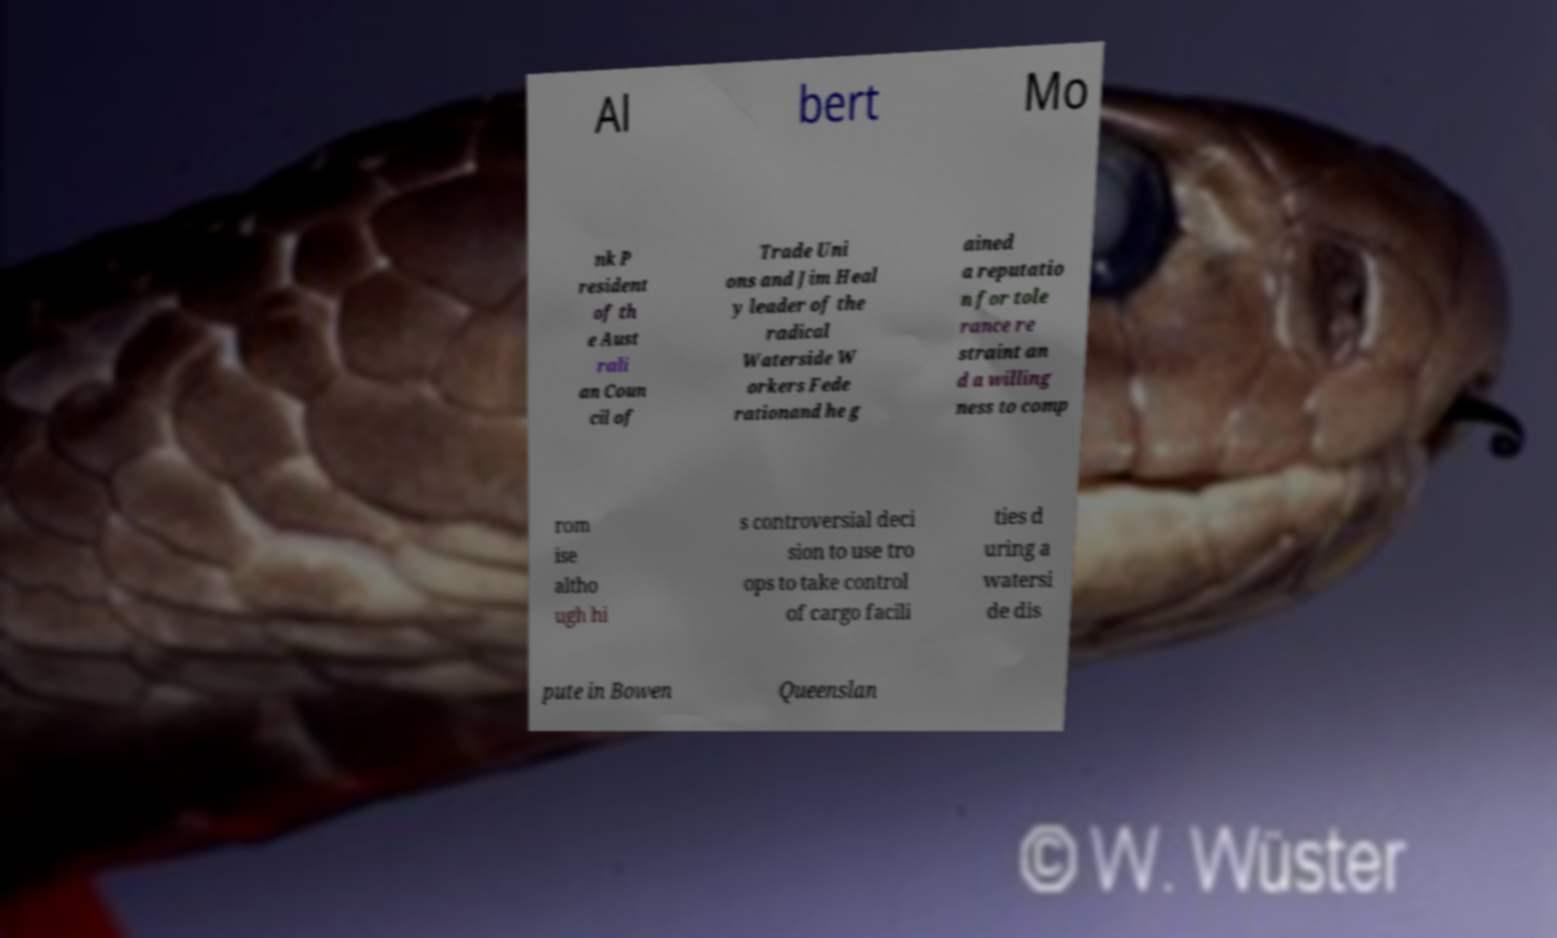Could you assist in decoding the text presented in this image and type it out clearly? Al bert Mo nk P resident of th e Aust rali an Coun cil of Trade Uni ons and Jim Heal y leader of the radical Waterside W orkers Fede rationand he g ained a reputatio n for tole rance re straint an d a willing ness to comp rom ise altho ugh hi s controversial deci sion to use tro ops to take control of cargo facili ties d uring a watersi de dis pute in Bowen Queenslan 